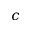<formula> <loc_0><loc_0><loc_500><loc_500>c</formula> 